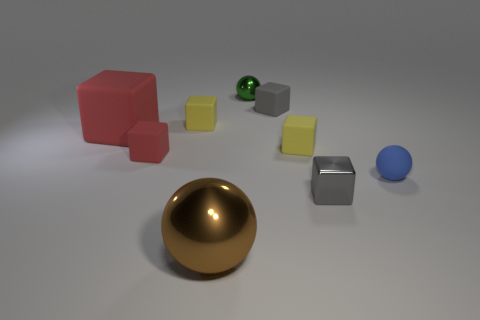What number of other things are the same material as the big red thing?
Your response must be concise. 5. Does the brown metal sphere have the same size as the cube that is to the left of the small red rubber object?
Offer a very short reply. Yes. Is the number of small yellow blocks that are on the right side of the small green shiny ball less than the number of small gray shiny blocks that are in front of the brown object?
Your response must be concise. No. There is a metallic sphere that is behind the large brown thing; how big is it?
Offer a very short reply. Small. Do the blue matte object and the green metallic object have the same size?
Provide a succinct answer. Yes. How many rubber cubes are to the left of the brown metal sphere and right of the green ball?
Your response must be concise. 0. How many blue things are small rubber blocks or small things?
Offer a terse response. 1. How many rubber objects are large yellow cylinders or spheres?
Provide a short and direct response. 1. Are any purple objects visible?
Ensure brevity in your answer.  No. Do the big metallic thing and the green shiny thing have the same shape?
Offer a very short reply. Yes. 